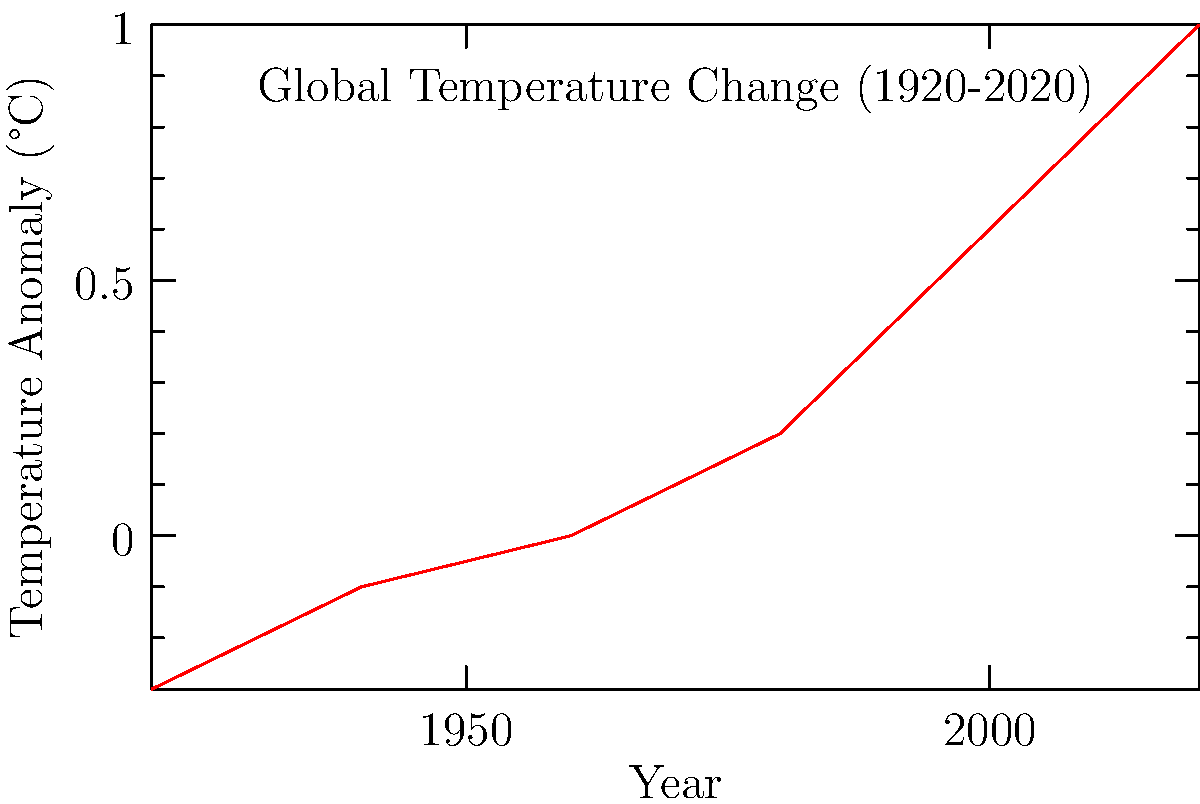Based on the graph, which natural phenomenon best explains the observed temperature trend from 1920 to 2020? 1. Analyze the graph: The temperature anomaly shows an overall increasing trend from 1920 to 2020.
2. Consider natural phenomena: Solar cycles, volcanic activity, and ocean circulation patterns are known to affect global temperatures.
3. Evaluate time scales: The graph shows a century-long trend, which is too long for most short-term natural cycles.
4. Consider ocean circulation: The Atlantic Multidecadal Oscillation (AMO) has a cycle of 60-80 years, which could partially explain the observed trend.
5. Exclude human factors: As a climate skeptic, we focus on natural explanations rather than human-induced warming.
6. Conclusion: The AMO is the most plausible natural phenomenon to explain the long-term trend shown in the graph.
Answer: Atlantic Multidecadal Oscillation (AMO) 